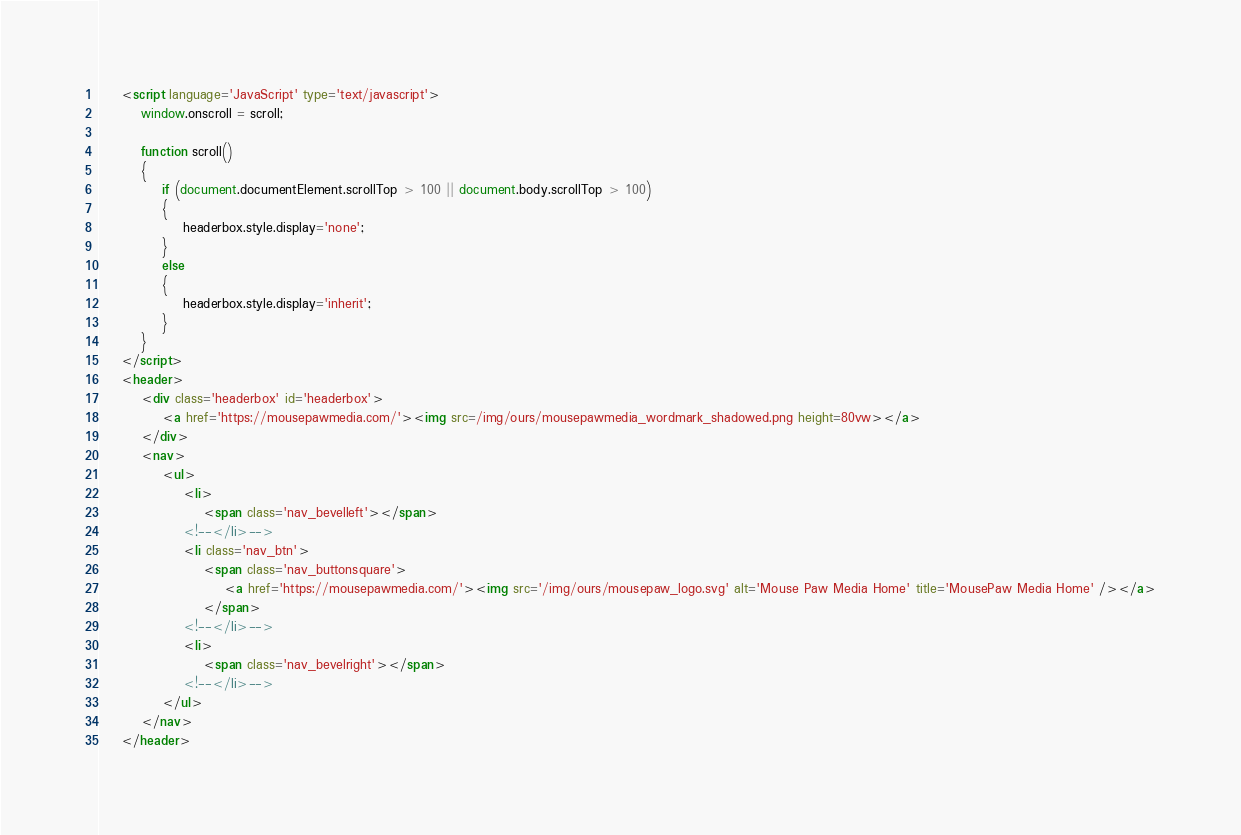<code> <loc_0><loc_0><loc_500><loc_500><_HTML_>    <script language='JavaScript' type='text/javascript'>
    	window.onscroll = scroll;

    	function scroll()
    	{
    		if (document.documentElement.scrollTop > 100 || document.body.scrollTop > 100)
    		{
    			headerbox.style.display='none';
    		}
    		else
    		{
    			headerbox.style.display='inherit';
    		}
    	}
    </script>
    <header>
        <div class='headerbox' id='headerbox'>
            <a href='https://mousepawmedia.com/'><img src=/img/ours/mousepawmedia_wordmark_shadowed.png height=80vw></a>
        </div>
        <nav>
            <ul>
                <li>
                    <span class='nav_bevelleft'></span>
                <!--</li>-->
                <li class='nav_btn'>
                    <span class='nav_buttonsquare'>
                        <a href='https://mousepawmedia.com/'><img src='/img/ours/mousepaw_logo.svg' alt='Mouse Paw Media Home' title='MousePaw Media Home' /></a>
                    </span>
                <!--</li>-->
                <li>
                    <span class='nav_bevelright'></span>
                <!--</li>-->
            </ul>
        </nav>
    </header>
</code> 